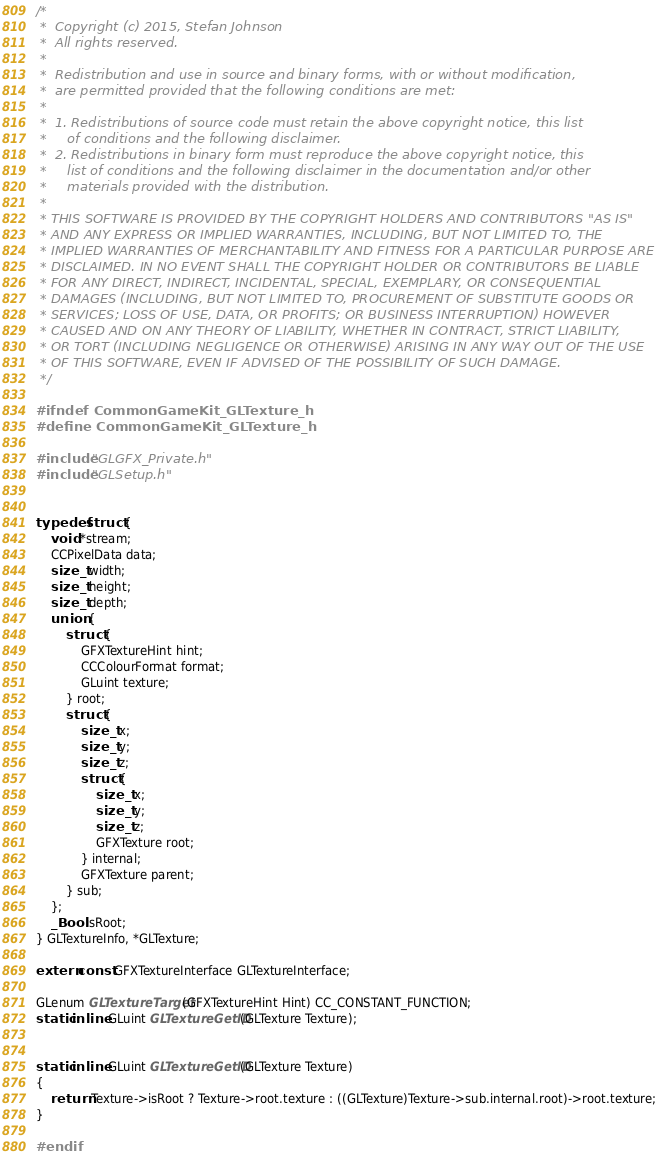<code> <loc_0><loc_0><loc_500><loc_500><_C_>/*
 *  Copyright (c) 2015, Stefan Johnson
 *  All rights reserved.
 *
 *  Redistribution and use in source and binary forms, with or without modification,
 *  are permitted provided that the following conditions are met:
 *
 *  1. Redistributions of source code must retain the above copyright notice, this list
 *     of conditions and the following disclaimer.
 *  2. Redistributions in binary form must reproduce the above copyright notice, this
 *     list of conditions and the following disclaimer in the documentation and/or other
 *     materials provided with the distribution.
 *
 * THIS SOFTWARE IS PROVIDED BY THE COPYRIGHT HOLDERS AND CONTRIBUTORS "AS IS"
 * AND ANY EXPRESS OR IMPLIED WARRANTIES, INCLUDING, BUT NOT LIMITED TO, THE
 * IMPLIED WARRANTIES OF MERCHANTABILITY AND FITNESS FOR A PARTICULAR PURPOSE ARE
 * DISCLAIMED. IN NO EVENT SHALL THE COPYRIGHT HOLDER OR CONTRIBUTORS BE LIABLE
 * FOR ANY DIRECT, INDIRECT, INCIDENTAL, SPECIAL, EXEMPLARY, OR CONSEQUENTIAL
 * DAMAGES (INCLUDING, BUT NOT LIMITED TO, PROCUREMENT OF SUBSTITUTE GOODS OR
 * SERVICES; LOSS OF USE, DATA, OR PROFITS; OR BUSINESS INTERRUPTION) HOWEVER
 * CAUSED AND ON ANY THEORY OF LIABILITY, WHETHER IN CONTRACT, STRICT LIABILITY,
 * OR TORT (INCLUDING NEGLIGENCE OR OTHERWISE) ARISING IN ANY WAY OUT OF THE USE
 * OF THIS SOFTWARE, EVEN IF ADVISED OF THE POSSIBILITY OF SUCH DAMAGE.
 */

#ifndef CommonGameKit_GLTexture_h
#define CommonGameKit_GLTexture_h

#include "GLGFX_Private.h"
#include "GLSetup.h"


typedef struct {
    void *stream;
    CCPixelData data;
    size_t width;
    size_t height;
    size_t depth;
    union {
        struct {
            GFXTextureHint hint;
            CCColourFormat format;
            GLuint texture;
        } root;
        struct {
            size_t x;
            size_t y;
            size_t z;
            struct {
                size_t x;
                size_t y;
                size_t z;
                GFXTexture root;
            } internal;
            GFXTexture parent;
        } sub;
    };
    _Bool isRoot;
} GLTextureInfo, *GLTexture;

extern const GFXTextureInterface GLTextureInterface;

GLenum GLTextureTarget(GFXTextureHint Hint) CC_CONSTANT_FUNCTION;
static inline GLuint GLTextureGetID(GLTexture Texture);


static inline GLuint GLTextureGetID(GLTexture Texture)
{
    return Texture->isRoot ? Texture->root.texture : ((GLTexture)Texture->sub.internal.root)->root.texture;
}

#endif
</code> 